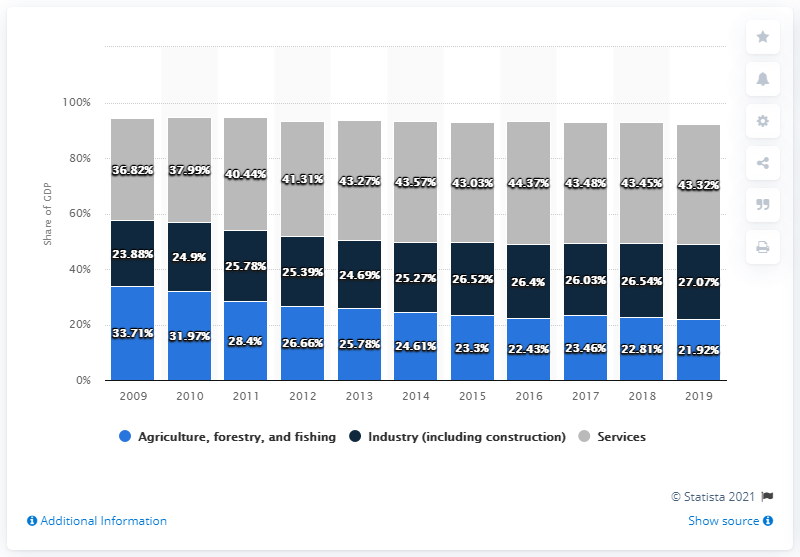Point out several critical features in this image. Over the years, there has been a significant difference in the maximum Gross Domestic Product (GDP) in the services sector and the minimum GDP in the industries. Specifically, the maximum GDP in the services sector was 20.49 times greater than the minimum GDP in the industries in a given year. In 2016, the services sector achieved the highest recorded GDP. 